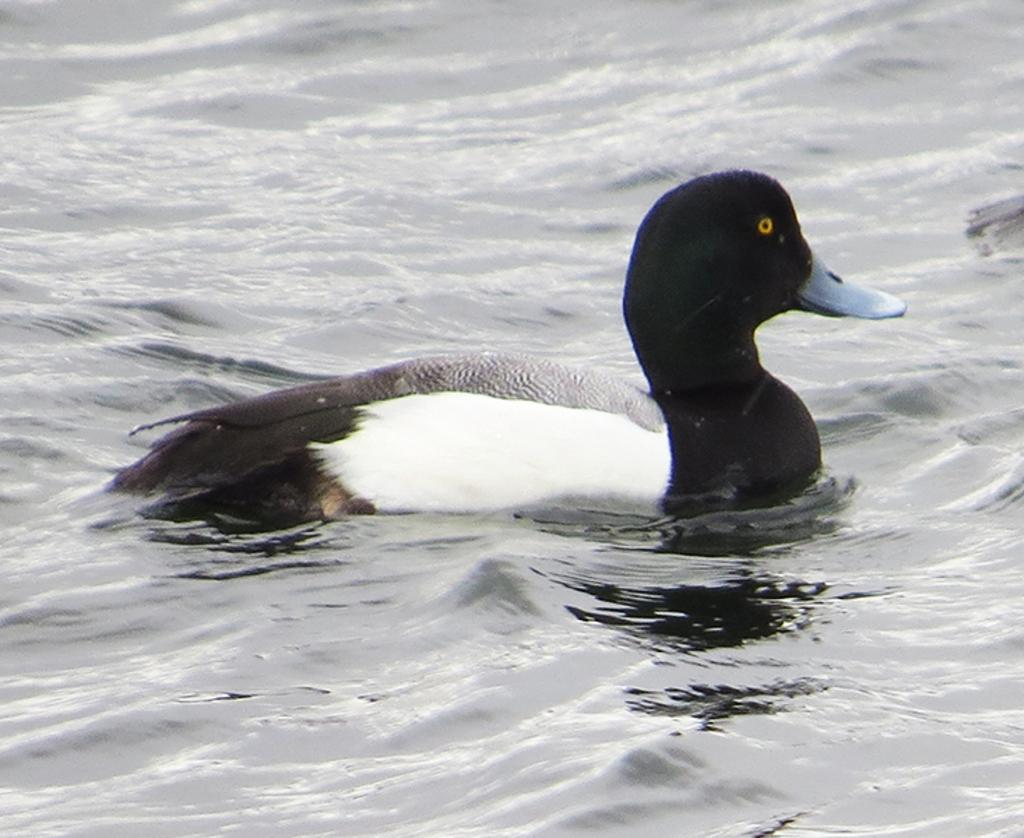What type of animal is in the image? There is a duck in the image. Where is the duck located in the image? The duck is in water. What is the name of the meal that the duck is preparing in the image? There is no indication in the image that the duck is preparing a meal, nor is there any reference to a meal or its name. 